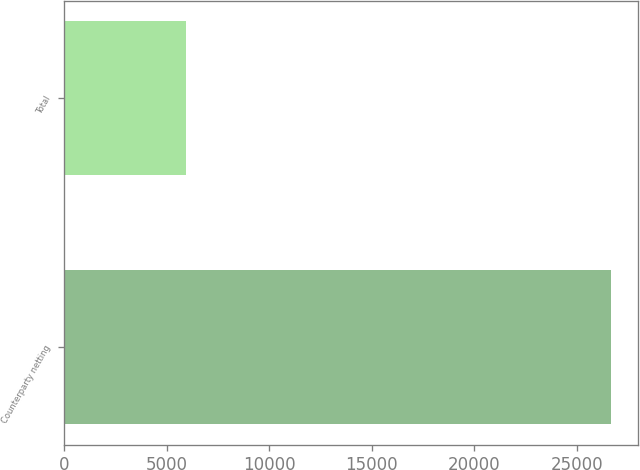<chart> <loc_0><loc_0><loc_500><loc_500><bar_chart><fcel>Counterparty netting<fcel>Total<nl><fcel>26664<fcel>5924<nl></chart> 